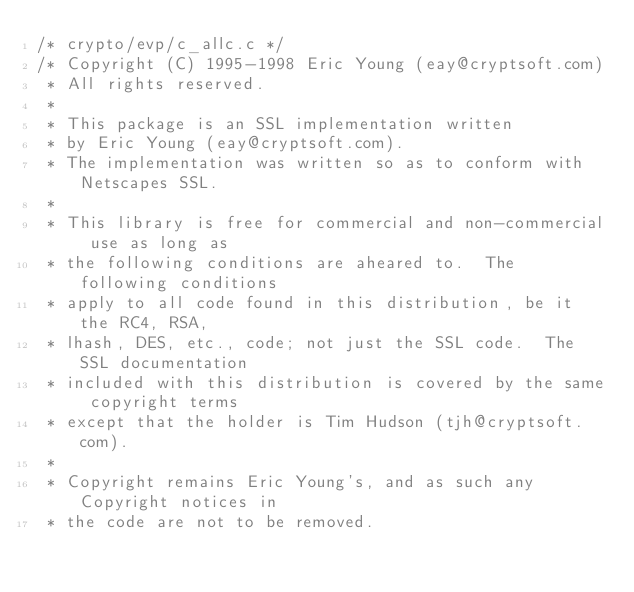Convert code to text. <code><loc_0><loc_0><loc_500><loc_500><_C_>/* crypto/evp/c_allc.c */
/* Copyright (C) 1995-1998 Eric Young (eay@cryptsoft.com)
 * All rights reserved.
 *
 * This package is an SSL implementation written
 * by Eric Young (eay@cryptsoft.com).
 * The implementation was written so as to conform with Netscapes SSL.
 *
 * This library is free for commercial and non-commercial use as long as
 * the following conditions are aheared to.  The following conditions
 * apply to all code found in this distribution, be it the RC4, RSA,
 * lhash, DES, etc., code; not just the SSL code.  The SSL documentation
 * included with this distribution is covered by the same copyright terms
 * except that the holder is Tim Hudson (tjh@cryptsoft.com).
 *
 * Copyright remains Eric Young's, and as such any Copyright notices in
 * the code are not to be removed.</code> 